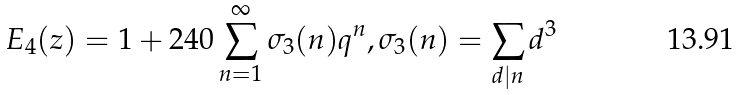Convert formula to latex. <formula><loc_0><loc_0><loc_500><loc_500>E _ { 4 } ( z ) = 1 + 2 4 0 \sum ^ { \infty } _ { n = 1 } \sigma _ { 3 } ( n ) q ^ { n } , \sigma _ { 3 } ( n ) = \sum _ { d | n } d ^ { 3 }</formula> 